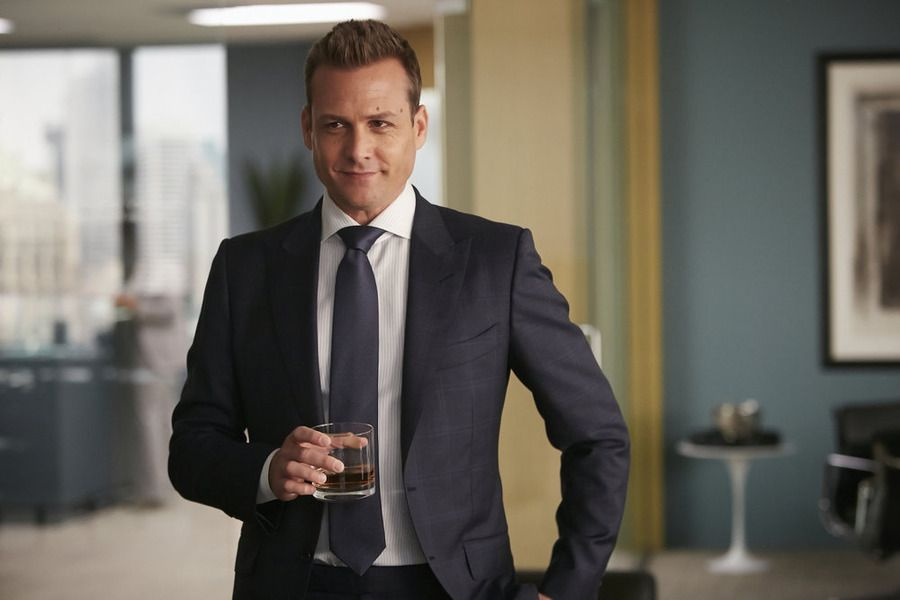What are the key elements in this picture? In the image, the central figure is a man dressed in a sleek dark blue suit, exuding confidence and authority. He holds a glass of whiskey, a symbol of his refined taste. The setting is a modern office with large windows offering a view of the cityscape, enhancing the sense of urban sophistication. On the wall behind him, there is artwork that adds a touch of elegance to the space. Overall, the composition conveys a blend of professionalism and high-class aesthetics. 